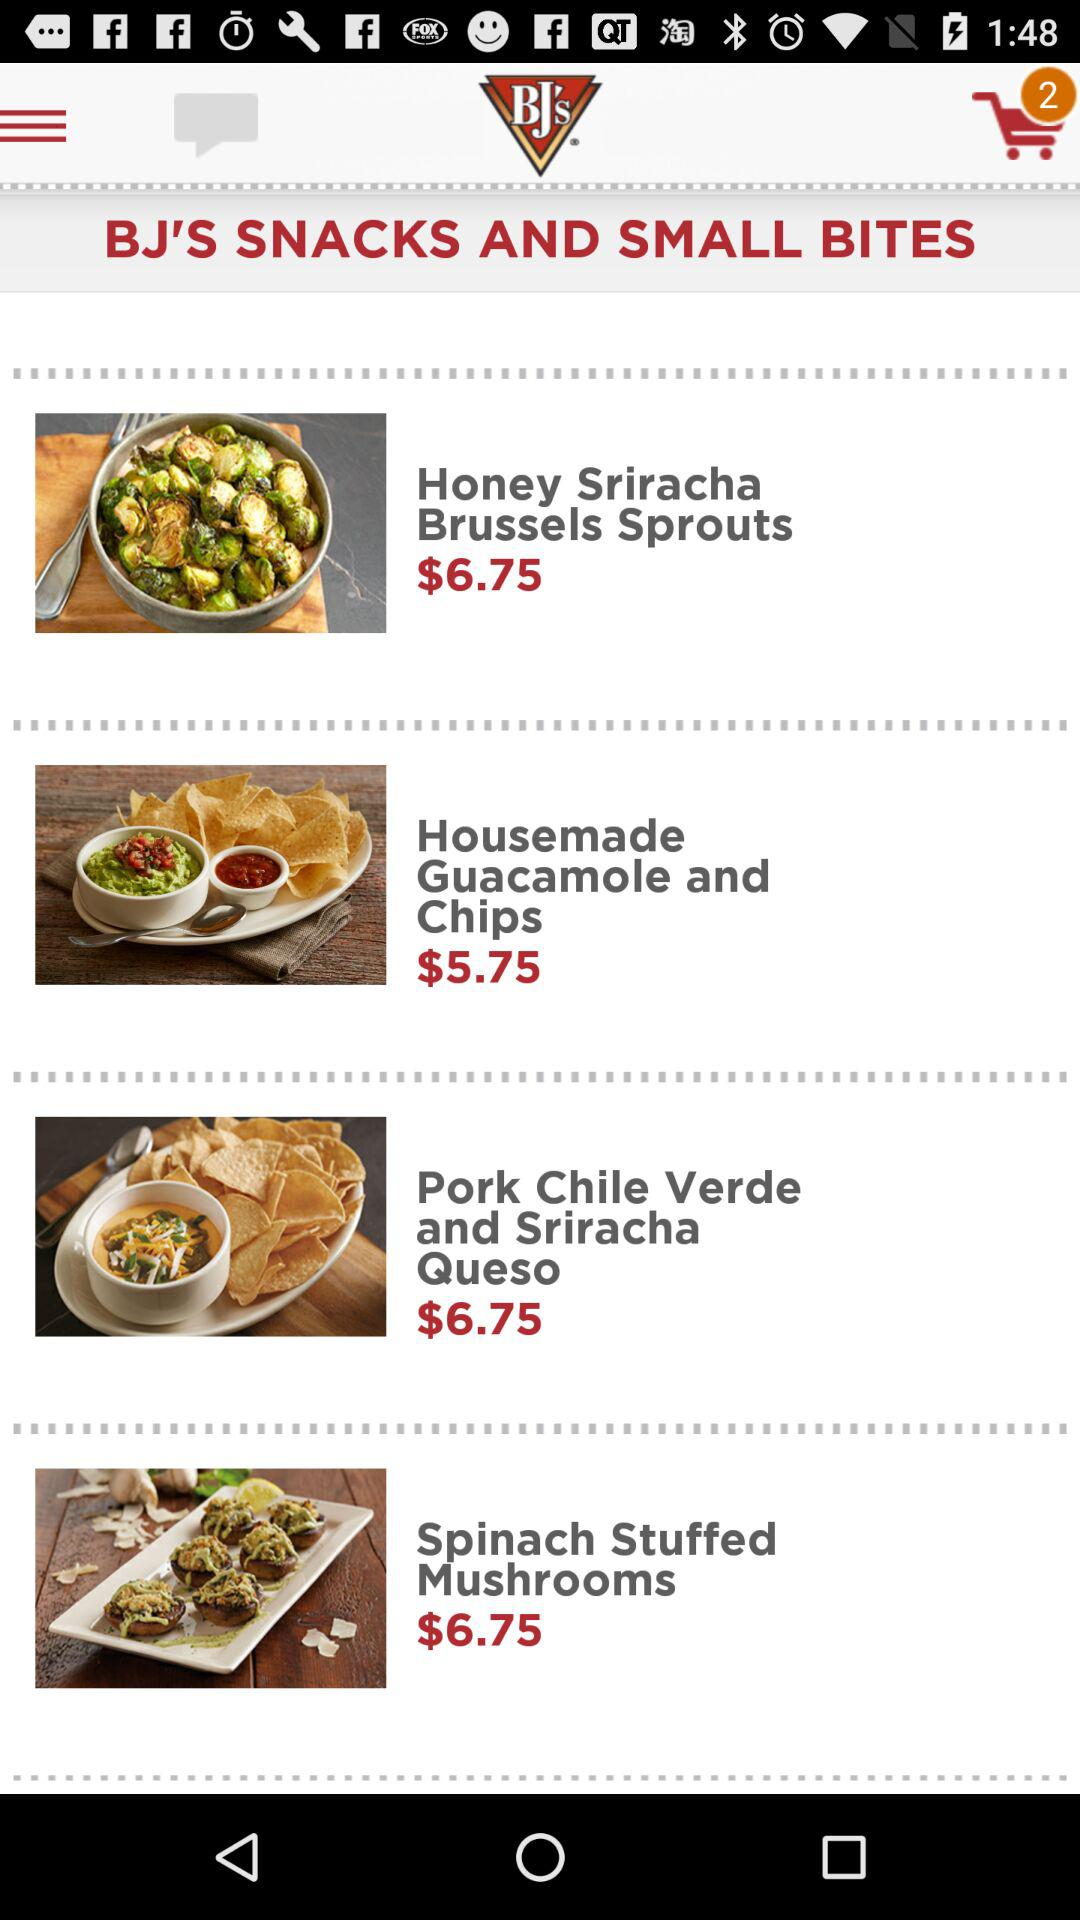How many items are priced over 6.00?
Answer the question using a single word or phrase. 3 